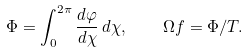<formula> <loc_0><loc_0><loc_500><loc_500>\Phi = \int _ { 0 } ^ { 2 \pi } \frac { d \varphi } { d \chi } \, d \chi , \quad \Omega f = \Phi / T .</formula> 